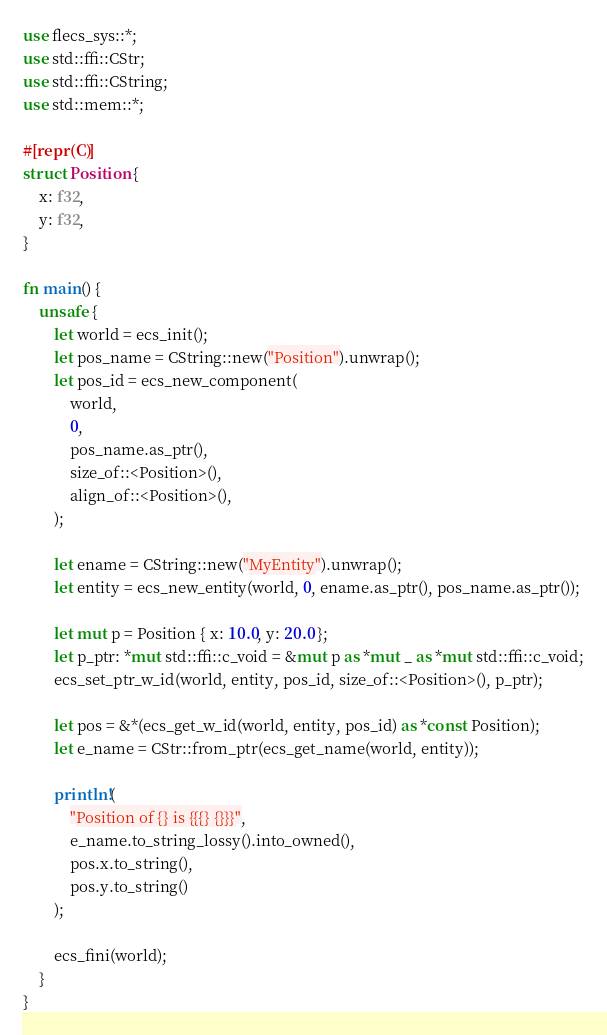<code> <loc_0><loc_0><loc_500><loc_500><_Rust_>use flecs_sys::*;
use std::ffi::CStr;
use std::ffi::CString;
use std::mem::*;

#[repr(C)]
struct Position {
    x: f32,
    y: f32,
}

fn main() {
    unsafe {
        let world = ecs_init();
        let pos_name = CString::new("Position").unwrap();
        let pos_id = ecs_new_component(
            world,
            0,
            pos_name.as_ptr(),
            size_of::<Position>(),
            align_of::<Position>(),
        );

        let ename = CString::new("MyEntity").unwrap();
        let entity = ecs_new_entity(world, 0, ename.as_ptr(), pos_name.as_ptr());

        let mut p = Position { x: 10.0, y: 20.0 };
        let p_ptr: *mut std::ffi::c_void = &mut p as *mut _ as *mut std::ffi::c_void;
        ecs_set_ptr_w_id(world, entity, pos_id, size_of::<Position>(), p_ptr);

        let pos = &*(ecs_get_w_id(world, entity, pos_id) as *const Position);
        let e_name = CStr::from_ptr(ecs_get_name(world, entity));

        println!(
            "Position of {} is {{{} {}}}",
            e_name.to_string_lossy().into_owned(),
            pos.x.to_string(),
            pos.y.to_string()
        );

        ecs_fini(world);
    }
}
</code> 